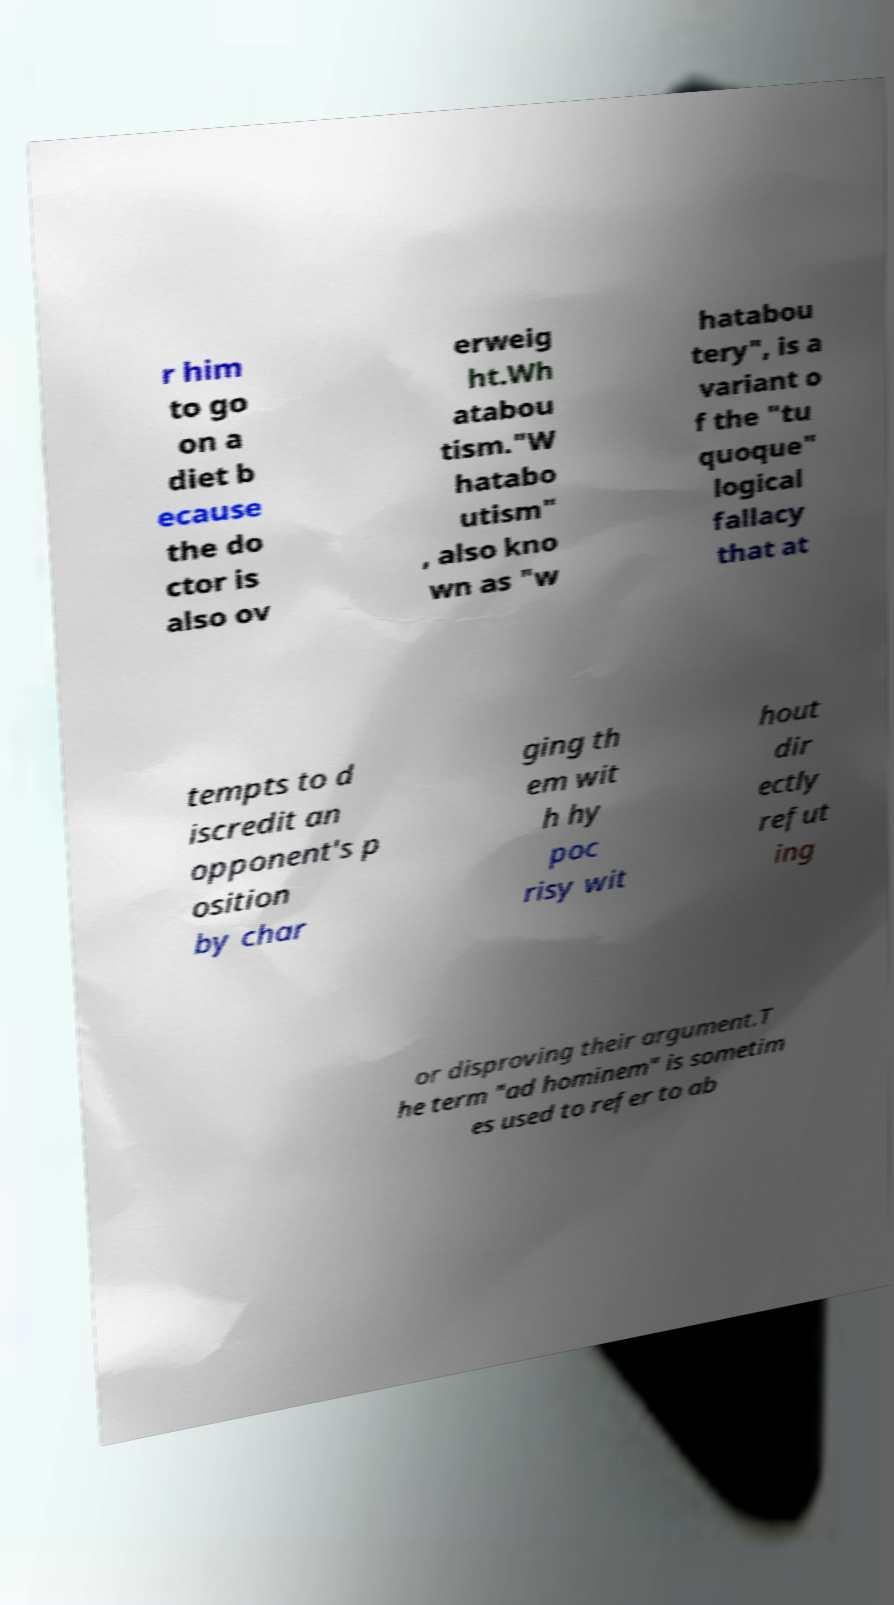I need the written content from this picture converted into text. Can you do that? r him to go on a diet b ecause the do ctor is also ov erweig ht.Wh atabou tism."W hatabo utism" , also kno wn as "w hatabou tery", is a variant o f the "tu quoque" logical fallacy that at tempts to d iscredit an opponent's p osition by char ging th em wit h hy poc risy wit hout dir ectly refut ing or disproving their argument.T he term "ad hominem" is sometim es used to refer to ab 